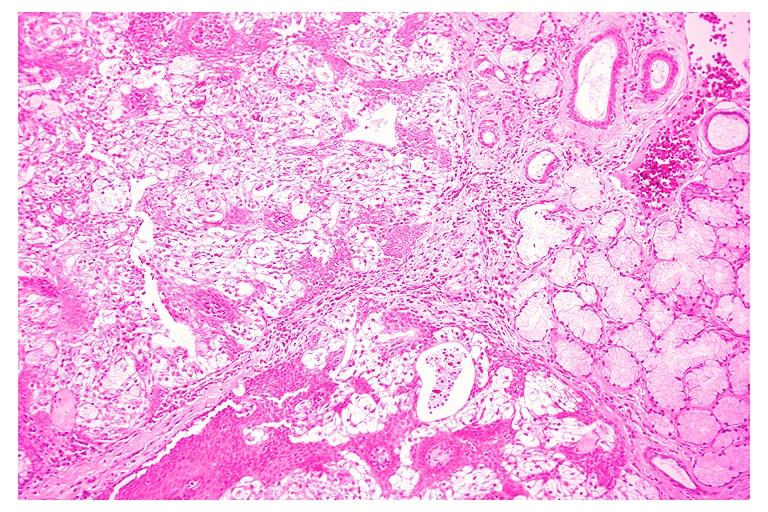does this image show mucoepidermoid carcinoma?
Answer the question using a single word or phrase. Yes 